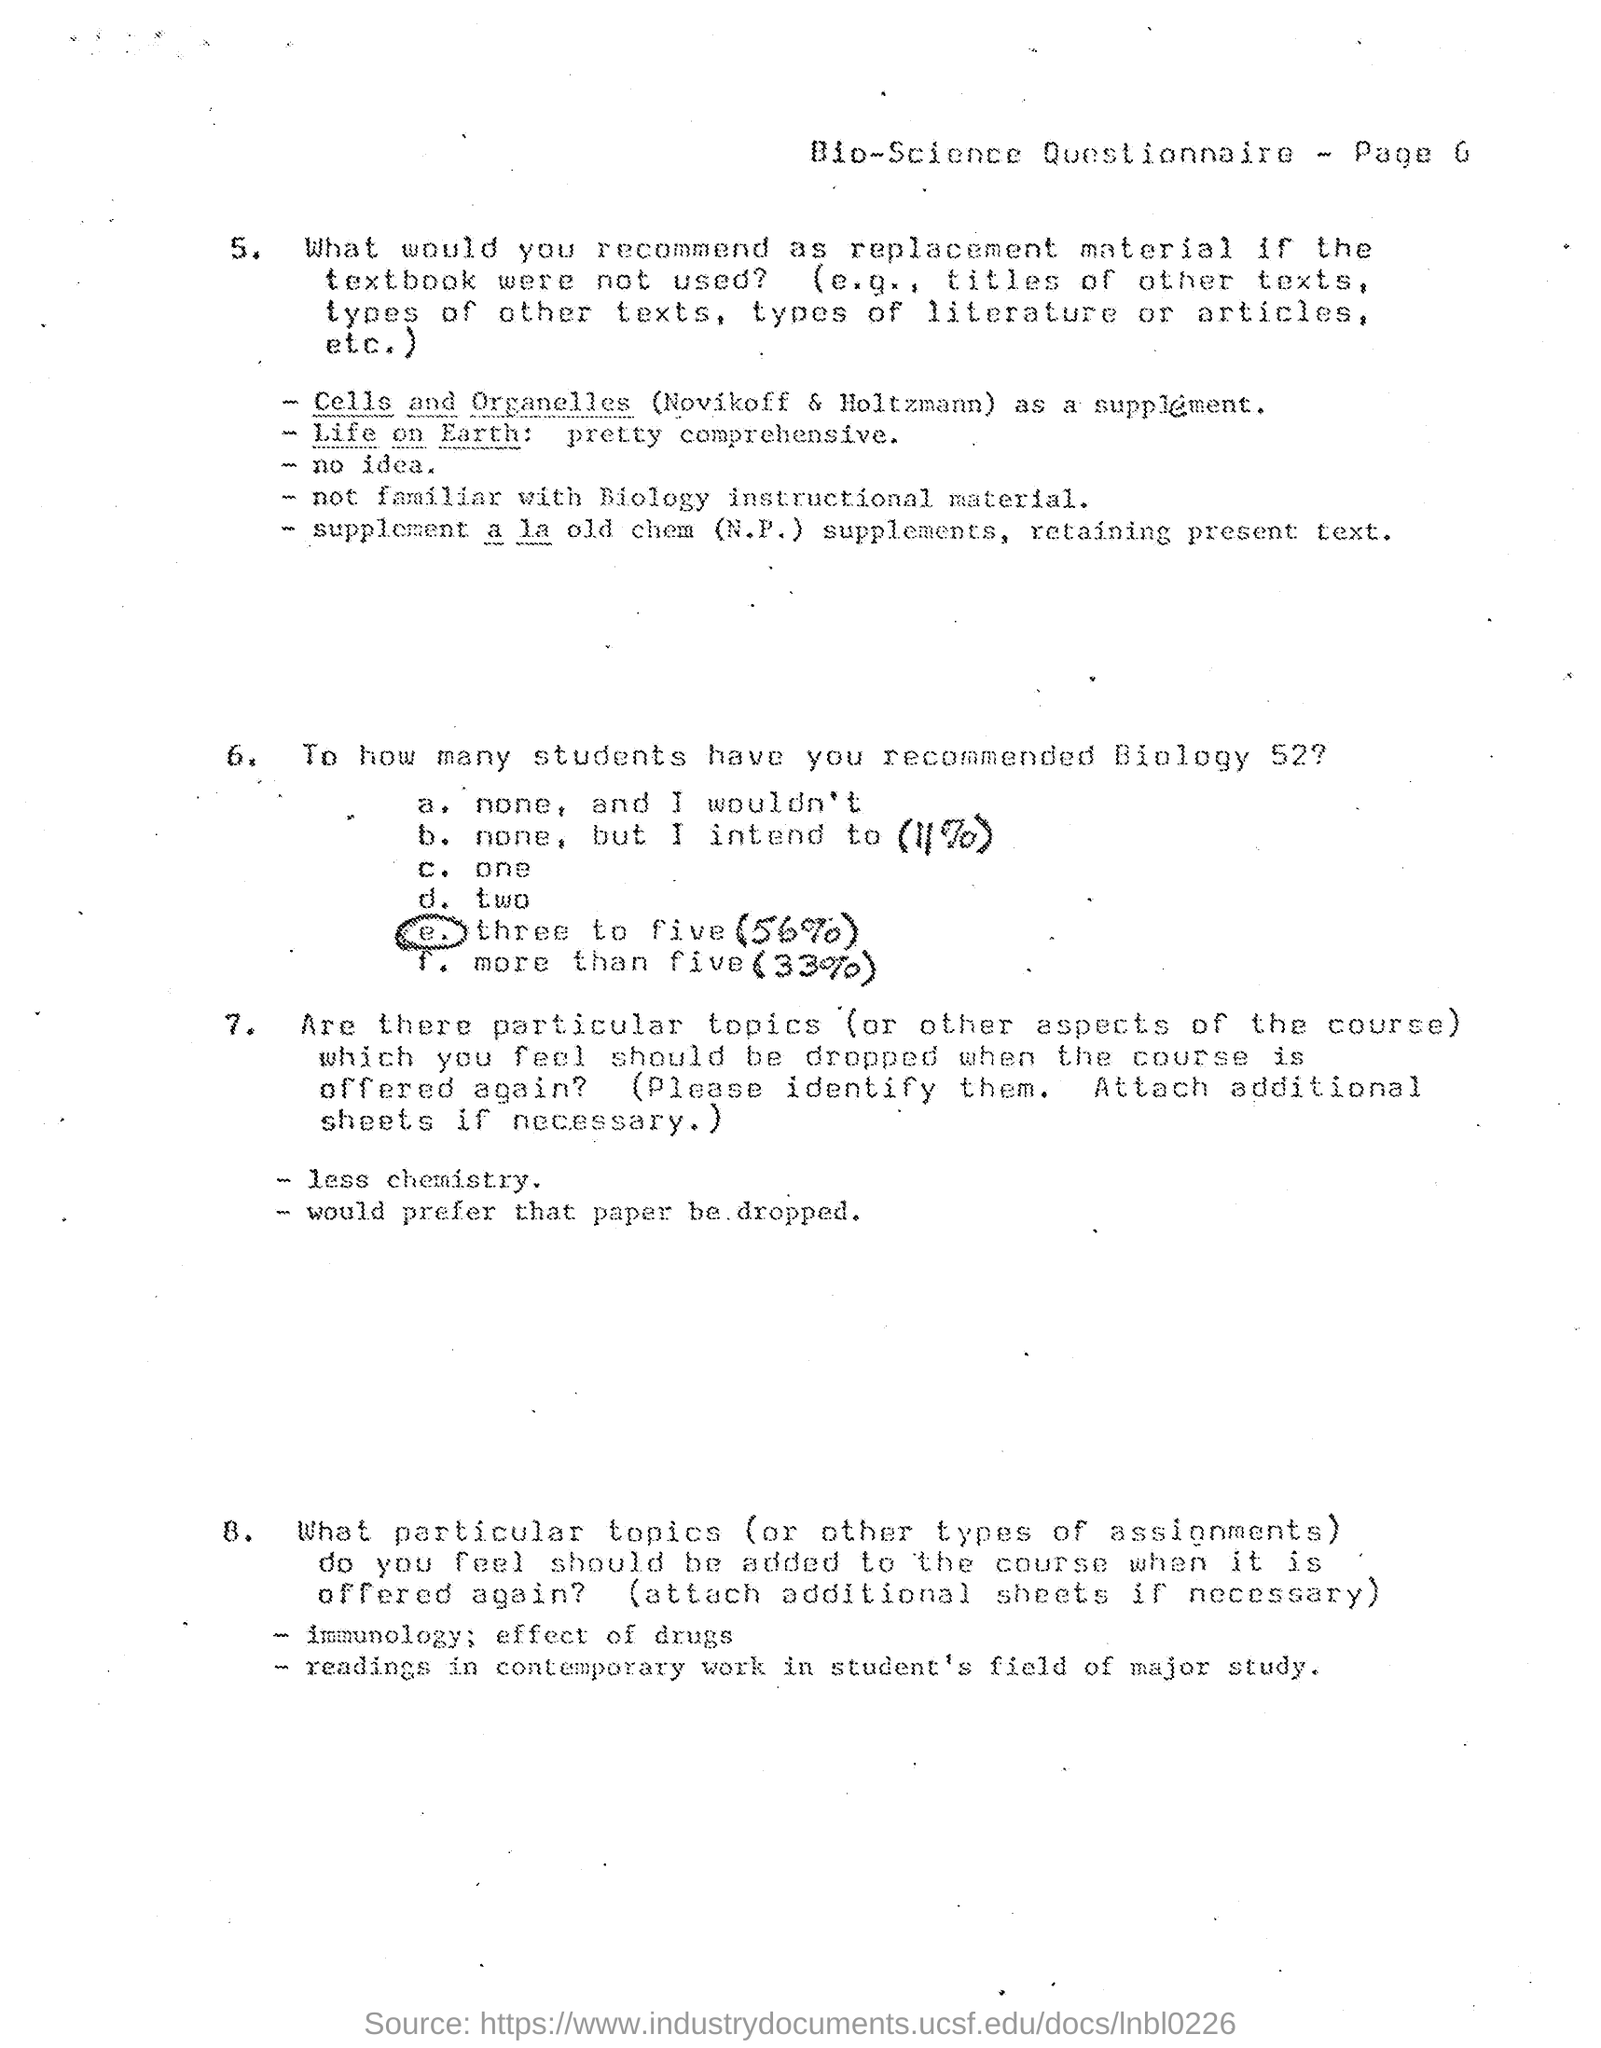What type of document is this ?
Provide a short and direct response. Bio-Science Questionnaire. Which page of " Bio-Science Questionnaire" is shown in the document ?
Your response must be concise. 6. 